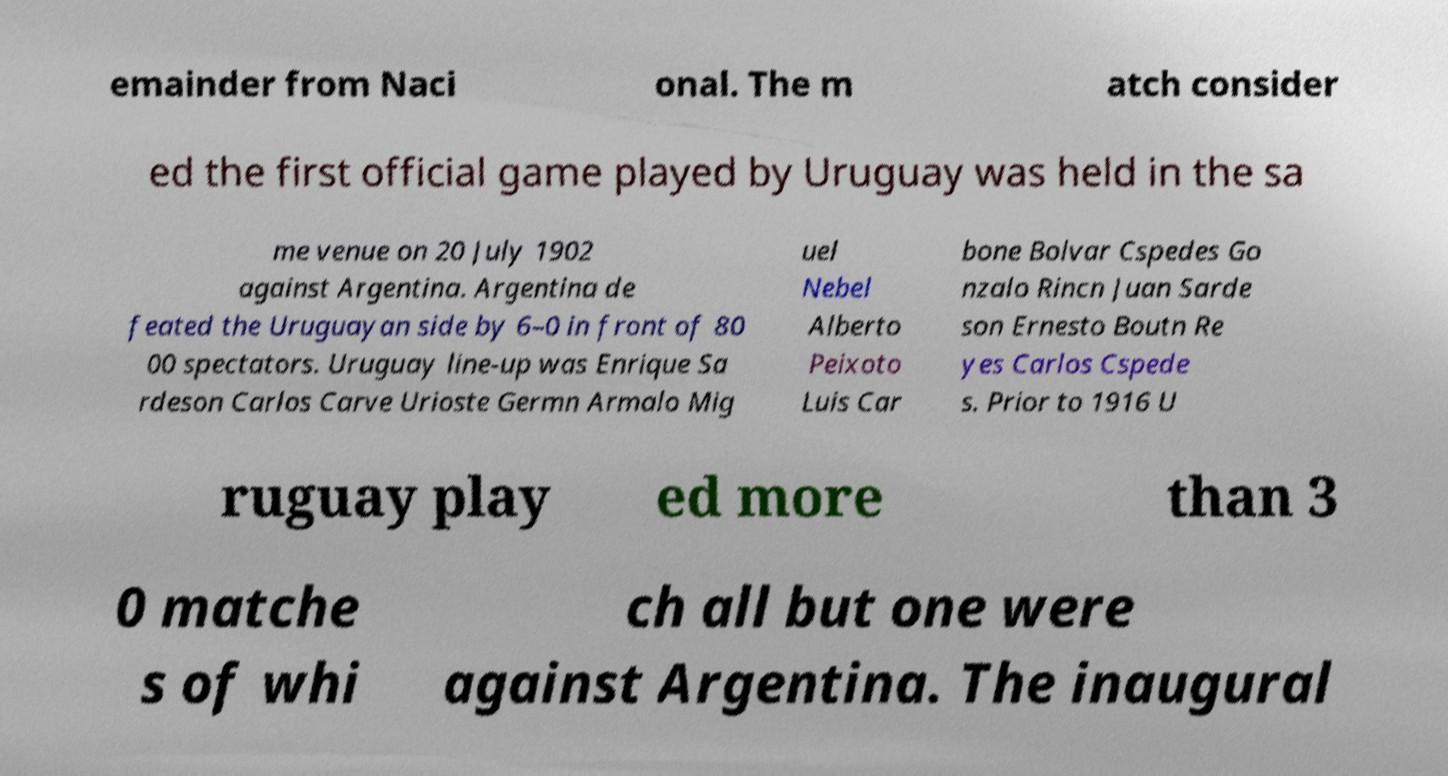For documentation purposes, I need the text within this image transcribed. Could you provide that? emainder from Naci onal. The m atch consider ed the first official game played by Uruguay was held in the sa me venue on 20 July 1902 against Argentina. Argentina de feated the Uruguayan side by 6–0 in front of 80 00 spectators. Uruguay line-up was Enrique Sa rdeson Carlos Carve Urioste Germn Armalo Mig uel Nebel Alberto Peixoto Luis Car bone Bolvar Cspedes Go nzalo Rincn Juan Sarde son Ernesto Boutn Re yes Carlos Cspede s. Prior to 1916 U ruguay play ed more than 3 0 matche s of whi ch all but one were against Argentina. The inaugural 